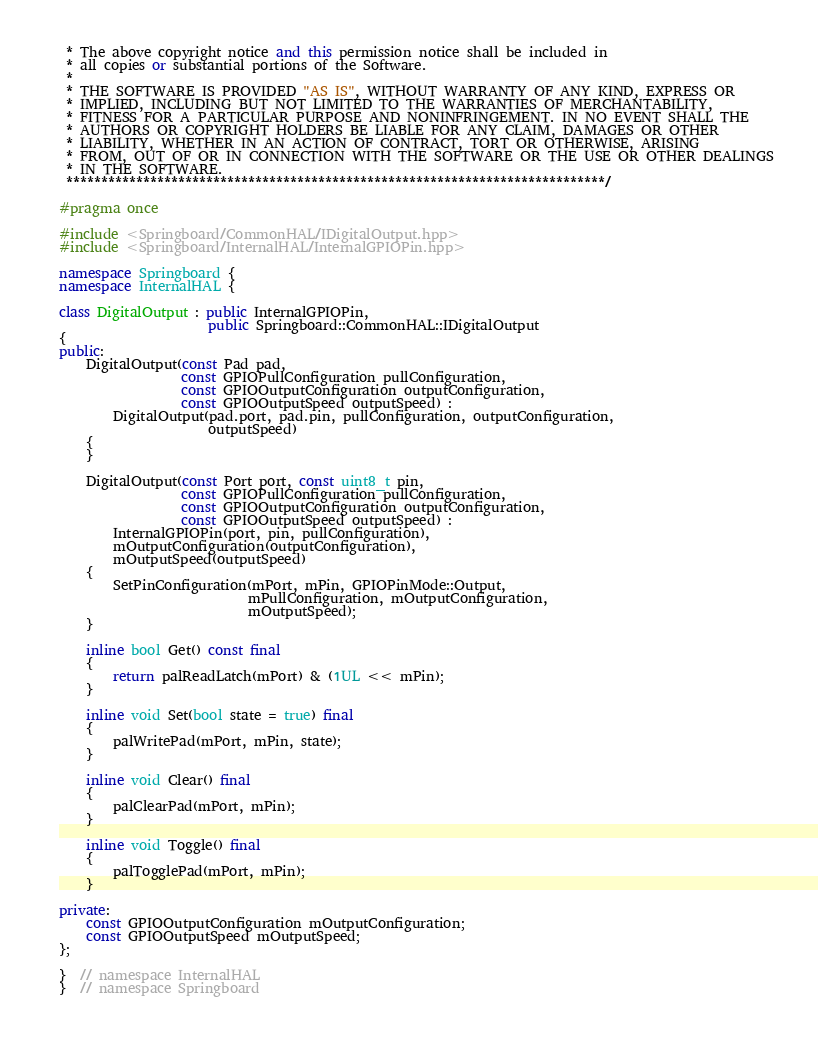Convert code to text. <code><loc_0><loc_0><loc_500><loc_500><_C++_> * The above copyright notice and this permission notice shall be included in
 * all copies or substantial portions of the Software.
 *
 * THE SOFTWARE IS PROVIDED "AS IS", WITHOUT WARRANTY OF ANY KIND, EXPRESS OR
 * IMPLIED, INCLUDING BUT NOT LIMITED TO THE WARRANTIES OF MERCHANTABILITY,
 * FITNESS FOR A PARTICULAR PURPOSE AND NONINFRINGEMENT. IN NO EVENT SHALL THE
 * AUTHORS OR COPYRIGHT HOLDERS BE LIABLE FOR ANY CLAIM, DAMAGES OR OTHER
 * LIABILITY, WHETHER IN AN ACTION OF CONTRACT, TORT OR OTHERWISE, ARISING
 * FROM, OUT OF OR IN CONNECTION WITH THE SOFTWARE OR THE USE OR OTHER DEALINGS
 * IN THE SOFTWARE.
 *****************************************************************************/

#pragma once

#include <Springboard/CommonHAL/IDigitalOutput.hpp>
#include <Springboard/InternalHAL/InternalGPIOPin.hpp>

namespace Springboard {
namespace InternalHAL {

class DigitalOutput : public InternalGPIOPin,
                      public Springboard::CommonHAL::IDigitalOutput
{
public:
    DigitalOutput(const Pad pad,
                  const GPIOPullConfiguration pullConfiguration,
                  const GPIOOutputConfiguration outputConfiguration,
                  const GPIOOutputSpeed outputSpeed) :
        DigitalOutput(pad.port, pad.pin, pullConfiguration, outputConfiguration,
                      outputSpeed)
    {
    }

    DigitalOutput(const Port port, const uint8_t pin,
                  const GPIOPullConfiguration pullConfiguration,
                  const GPIOOutputConfiguration outputConfiguration,
                  const GPIOOutputSpeed outputSpeed) :
        InternalGPIOPin(port, pin, pullConfiguration),
        mOutputConfiguration(outputConfiguration),
        mOutputSpeed(outputSpeed)
    {
        SetPinConfiguration(mPort, mPin, GPIOPinMode::Output,
                            mPullConfiguration, mOutputConfiguration,
                            mOutputSpeed);
    }

    inline bool Get() const final
    {
        return palReadLatch(mPort) & (1UL << mPin);
    }

    inline void Set(bool state = true) final
    {
        palWritePad(mPort, mPin, state);
    }

    inline void Clear() final
    {
        palClearPad(mPort, mPin);
    }

    inline void Toggle() final
    {
        palTogglePad(mPort, mPin);
    }

private:
    const GPIOOutputConfiguration mOutputConfiguration;
    const GPIOOutputSpeed mOutputSpeed;
};

}  // namespace InternalHAL
}  // namespace Springboard
</code> 